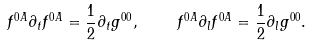Convert formula to latex. <formula><loc_0><loc_0><loc_500><loc_500>f ^ { 0 A } \partial _ { t } f ^ { 0 A } = \frac { 1 } { 2 } \partial _ { t } g ^ { 0 0 } , \quad f ^ { 0 A } \partial _ { l } f ^ { 0 A } = \frac { 1 } { 2 } \partial _ { l } g ^ { 0 0 } .</formula> 